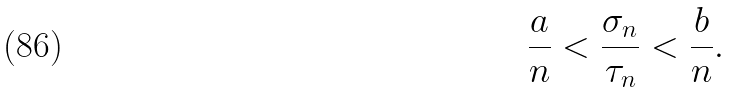<formula> <loc_0><loc_0><loc_500><loc_500>\frac { a } { n } < \frac { \sigma _ { n } } { \tau _ { n } } < \frac { b } { n } .</formula> 